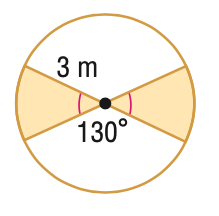Question: Find the area of the shaded region. Round to the nearest tenth.
Choices:
A. 3.9
B. 5.2
C. 7.9
D. 20.4
Answer with the letter. Answer: C 